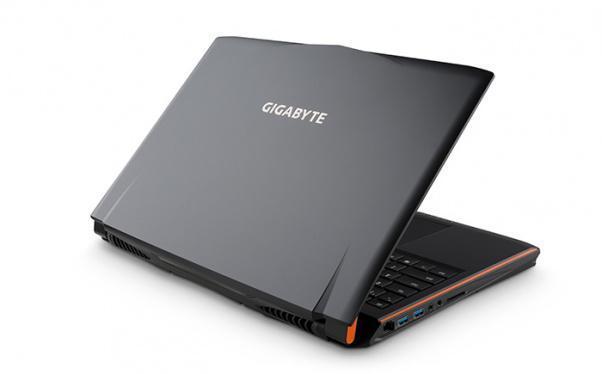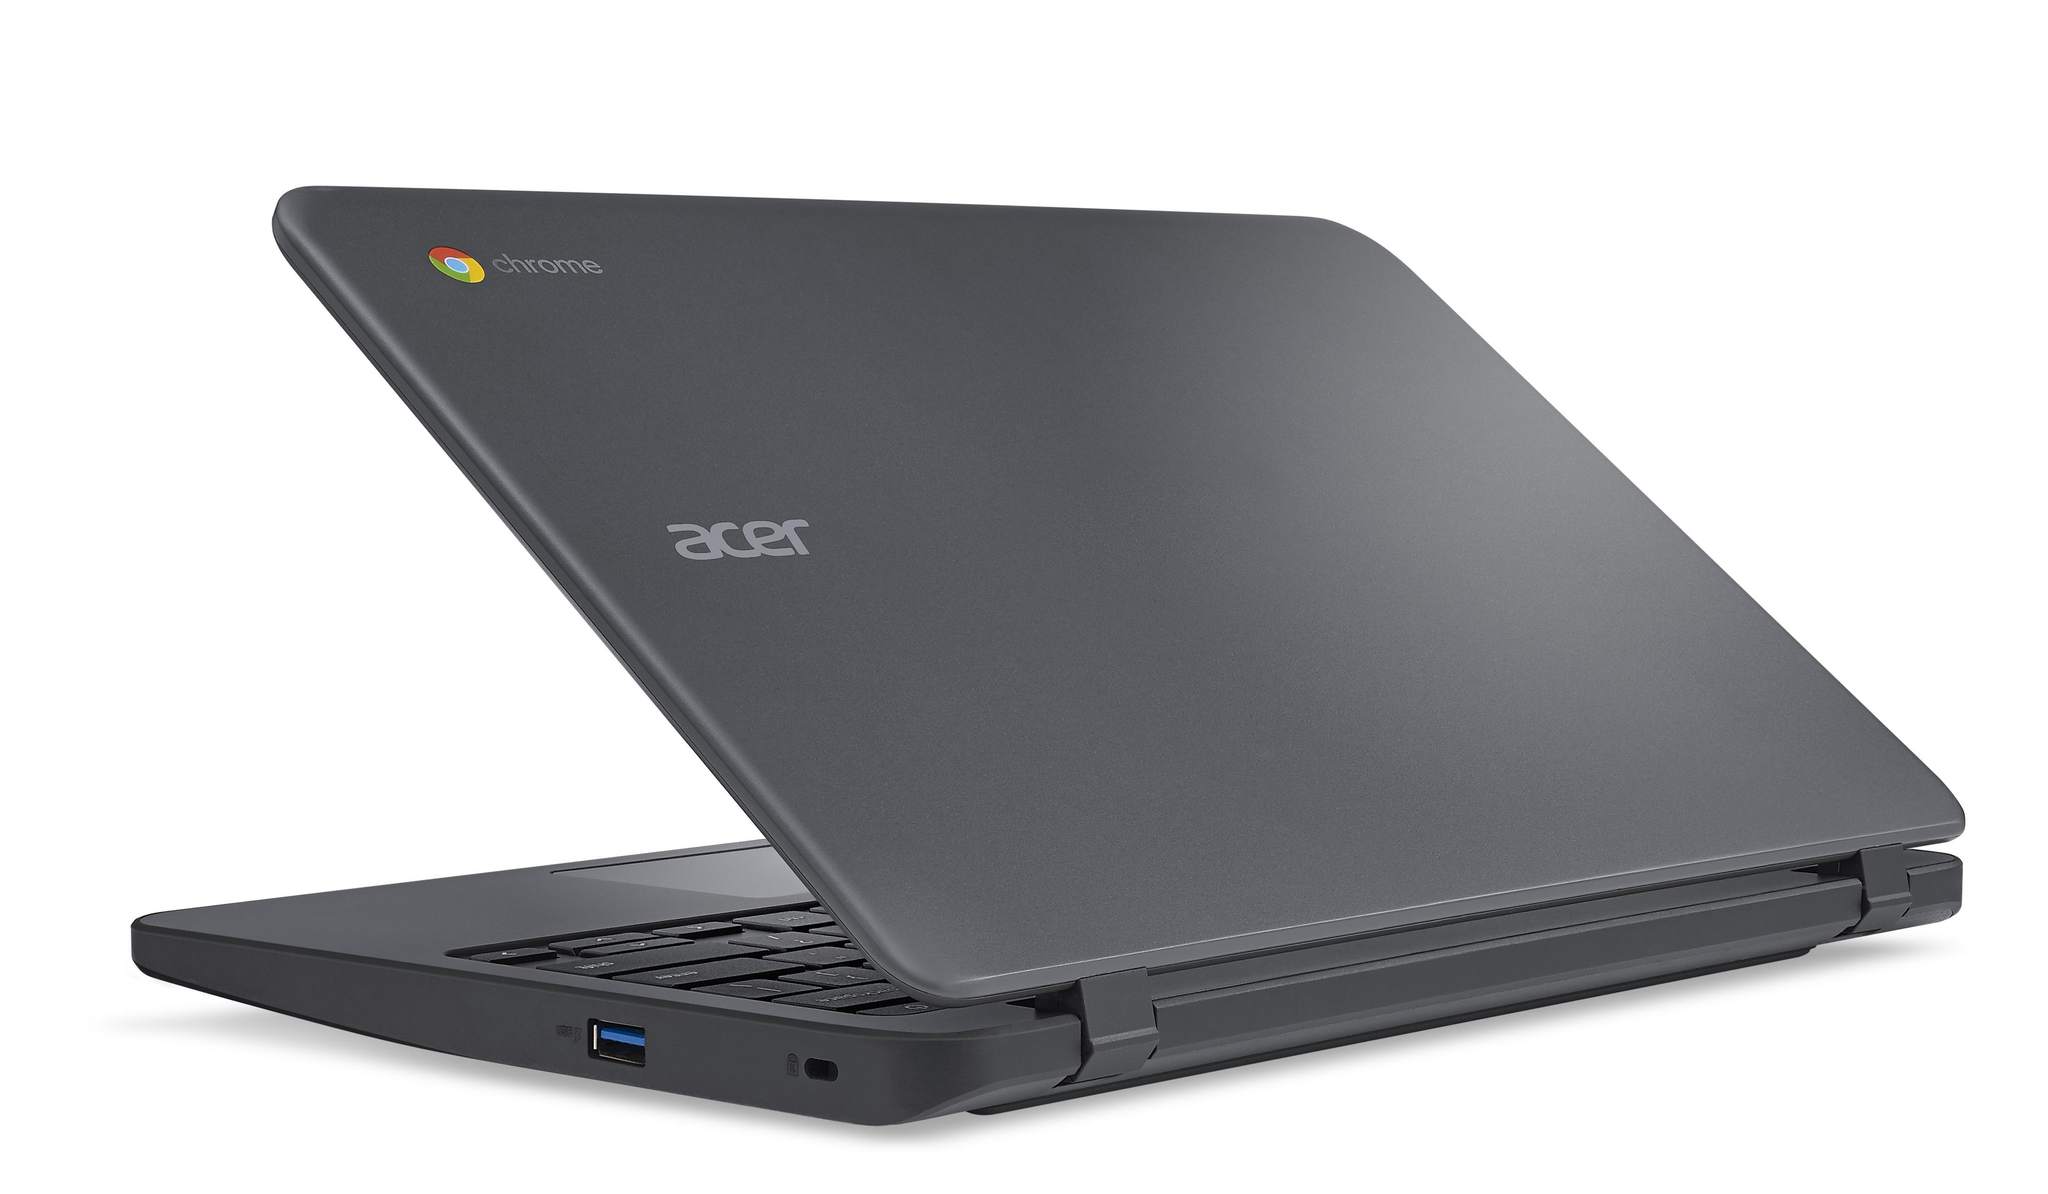The first image is the image on the left, the second image is the image on the right. Considering the images on both sides, is "Each image contains a single laptop, and one image features a laptop with the screen open to at least a right angle and visible, and the other image shows a laptop facing backward and open at less than 90-degrees." valid? Answer yes or no. No. The first image is the image on the left, the second image is the image on the right. Analyze the images presented: Is the assertion "The left and right image contains the same number of laptops with one half opened and the other fully opened." valid? Answer yes or no. No. 